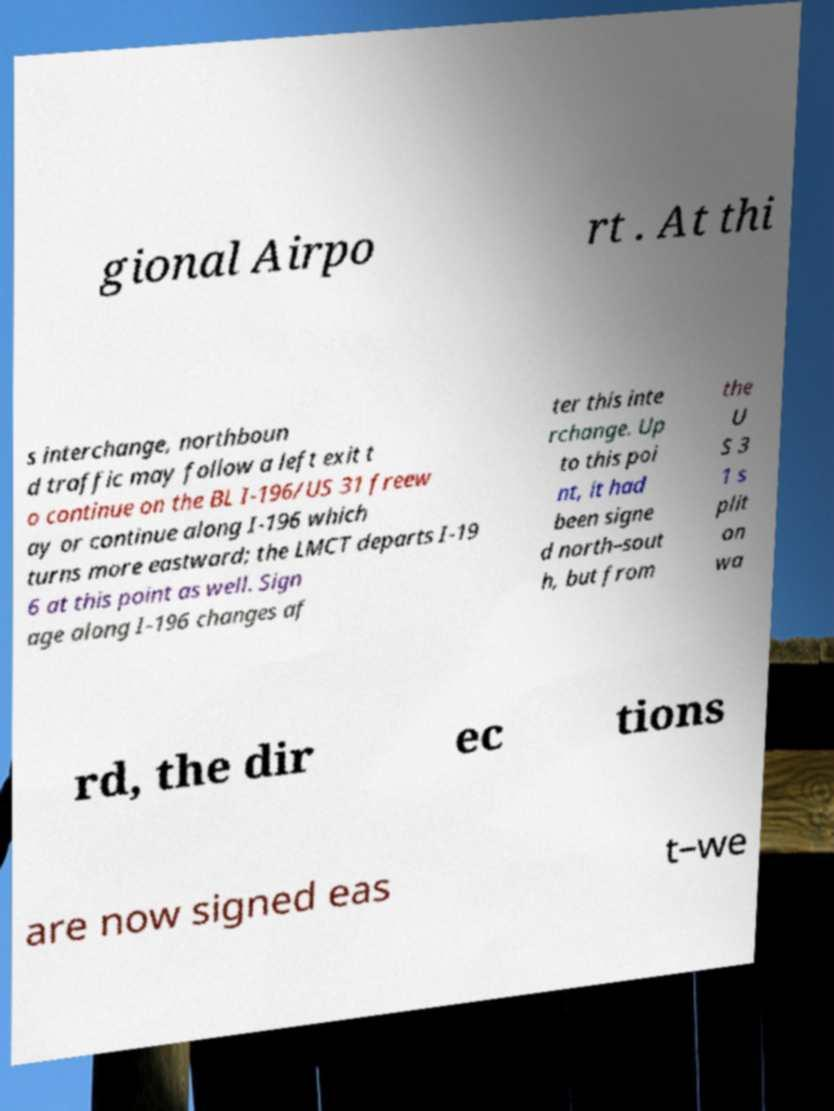Could you extract and type out the text from this image? gional Airpo rt . At thi s interchange, northboun d traffic may follow a left exit t o continue on the BL I-196/US 31 freew ay or continue along I-196 which turns more eastward; the LMCT departs I-19 6 at this point as well. Sign age along I-196 changes af ter this inte rchange. Up to this poi nt, it had been signe d north–sout h, but from the U S 3 1 s plit on wa rd, the dir ec tions are now signed eas t–we 